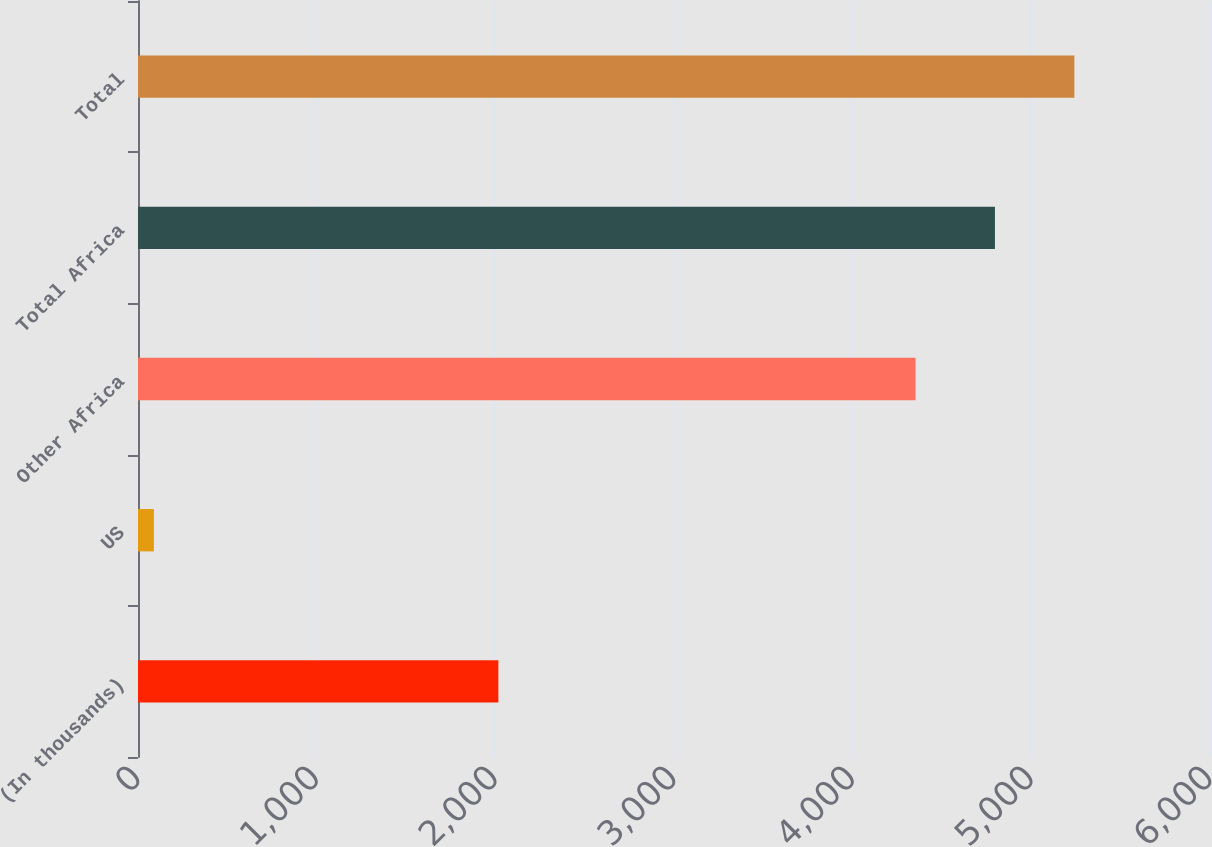Convert chart. <chart><loc_0><loc_0><loc_500><loc_500><bar_chart><fcel>(In thousands)<fcel>US<fcel>Other Africa<fcel>Total Africa<fcel>Total<nl><fcel>2017<fcel>89<fcel>4352<fcel>4796.4<fcel>5240.8<nl></chart> 